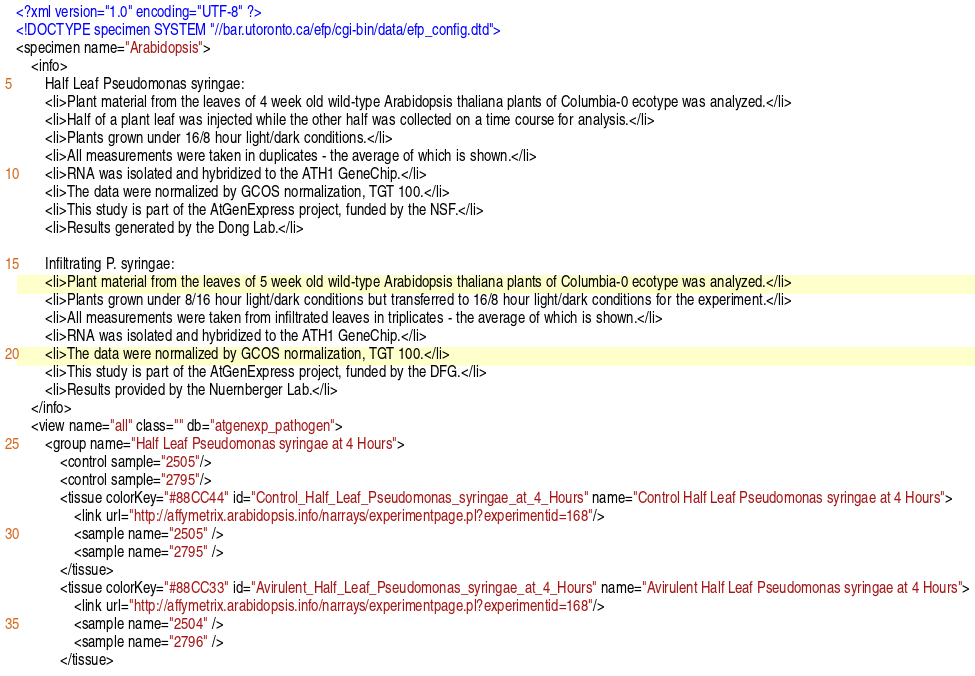Convert code to text. <code><loc_0><loc_0><loc_500><loc_500><_XML_><?xml version="1.0" encoding="UTF-8" ?> 
<!DOCTYPE specimen SYSTEM "//bar.utoronto.ca/efp/cgi-bin/data/efp_config.dtd">
<specimen name="Arabidopsis">
	<info>
		Half Leaf Pseudomonas syringae:
		<li>Plant material from the leaves of 4 week old wild-type Arabidopsis thaliana plants of Columbia-0 ecotype was analyzed.</li>
		<li>Half of a plant leaf was injected while the other half was collected on a time course for analysis.</li>
		<li>Plants grown under 16/8 hour light/dark conditions.</li>
		<li>All measurements were taken in duplicates - the average of which is shown.</li>
		<li>RNA was isolated and hybridized to the ATH1 GeneChip.</li>
		<li>The data were normalized by GCOS normalization, TGT 100.</li>
		<li>This study is part of the AtGenExpress project, funded by the NSF.</li>
		<li>Results generated by the Dong Lab.</li>
		
		Infiltrating P. syringae: 
		<li>Plant material from the leaves of 5 week old wild-type Arabidopsis thaliana plants of Columbia-0 ecotype was analyzed.</li>
		<li>Plants grown under 8/16 hour light/dark conditions but transferred to 16/8 hour light/dark conditions for the experiment.</li>
		<li>All measurements were taken from infiltrated leaves in triplicates - the average of which is shown.</li>
		<li>RNA was isolated and hybridized to the ATH1 GeneChip.</li>
		<li>The data were normalized by GCOS normalization, TGT 100.</li>
		<li>This study is part of the AtGenExpress project, funded by the DFG.</li>
		<li>Results provided by the Nuernberger Lab.</li>
	</info>
	<view name="all" class="" db="atgenexp_pathogen">
		<group name="Half Leaf Pseudomonas syringae at 4 Hours">
			<control sample="2505"/>
			<control sample="2795"/>
			<tissue colorKey="#88CC44" id="Control_Half_Leaf_Pseudomonas_syringae_at_4_Hours" name="Control Half Leaf Pseudomonas syringae at 4 Hours">
				<link url="http://affymetrix.arabidopsis.info/narrays/experimentpage.pl?experimentid=168"/>
				<sample name="2505" /> 
				<sample name="2795" />  
			</tissue>
			<tissue colorKey="#88CC33" id="Avirulent_Half_Leaf_Pseudomonas_syringae_at_4_Hours" name="Avirulent Half Leaf Pseudomonas syringae at 4 Hours">
				<link url="http://affymetrix.arabidopsis.info/narrays/experimentpage.pl?experimentid=168"/>
				<sample name="2504" /> 
				<sample name="2796" /> 
			</tissue></code> 